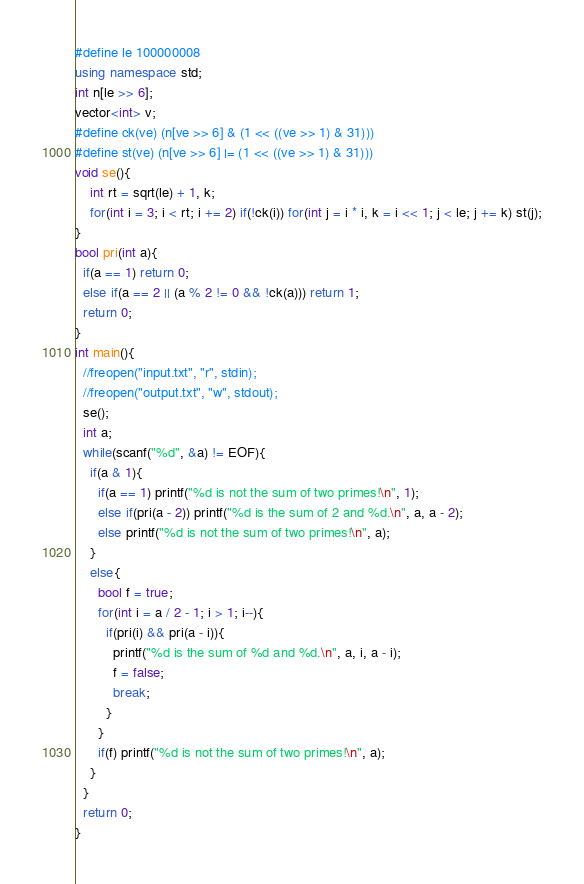Convert code to text. <code><loc_0><loc_0><loc_500><loc_500><_C++_>#define le 100000008
using namespace std;
int n[le >> 6];
vector<int> v;
#define ck(ve) (n[ve >> 6] & (1 << ((ve >> 1) & 31)))
#define st(ve) (n[ve >> 6] |= (1 << ((ve >> 1) & 31)))
void se(){
    int rt = sqrt(le) + 1, k;
    for(int i = 3; i < rt; i += 2) if(!ck(i)) for(int j = i * i, k = i << 1; j < le; j += k) st(j);
}
bool pri(int a){
  if(a == 1) return 0;
  else if(a == 2 || (a % 2 != 0 && !ck(a))) return 1;
  return 0;
}
int main(){
  //freopen("input.txt", "r", stdin);
  //freopen("output.txt", "w", stdout);
  se();
  int a;
  while(scanf("%d", &a) != EOF){
    if(a & 1){
      if(a == 1) printf("%d is not the sum of two primes!\n", 1);
      else if(pri(a - 2)) printf("%d is the sum of 2 and %d.\n", a, a - 2);
      else printf("%d is not the sum of two primes!\n", a);
    }
    else{
      bool f = true;
      for(int i = a / 2 - 1; i > 1; i--){
        if(pri(i) && pri(a - i)){
          printf("%d is the sum of %d and %d.\n", a, i, a - i);
          f = false;
          break;
        }
      }
      if(f) printf("%d is not the sum of two primes!\n", a);
    }
  }
  return 0;
}
</code> 